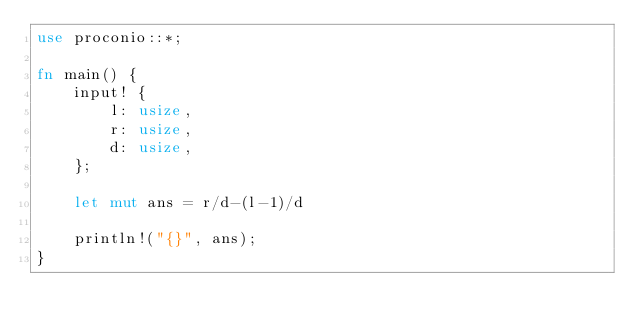<code> <loc_0><loc_0><loc_500><loc_500><_Rust_>use proconio::*;
 
fn main() {
    input! {
        l: usize,
        r: usize,
        d: usize,
    };
 
    let mut ans = r/d-(l-1)/d
 
    println!("{}", ans);
}</code> 